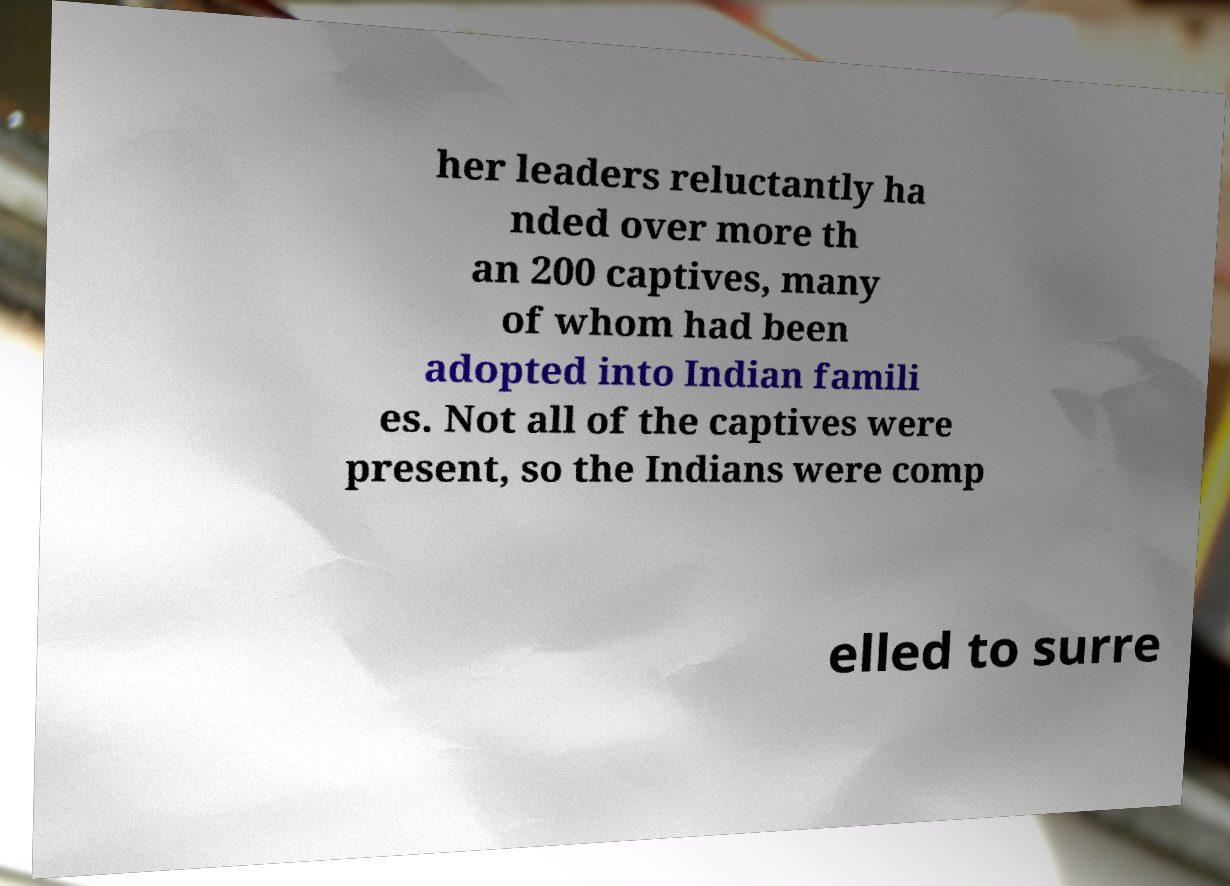Can you read and provide the text displayed in the image?This photo seems to have some interesting text. Can you extract and type it out for me? her leaders reluctantly ha nded over more th an 200 captives, many of whom had been adopted into Indian famili es. Not all of the captives were present, so the Indians were comp elled to surre 